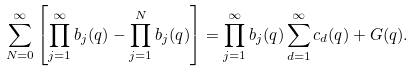Convert formula to latex. <formula><loc_0><loc_0><loc_500><loc_500>\sum _ { N = 0 } ^ { \infty } \left [ \prod _ { j = 1 } ^ { \infty } b _ { j } ( q ) - \prod _ { j = 1 } ^ { N } b _ { j } ( q ) \right ] = \prod _ { j = 1 } ^ { \infty } b _ { j } ( q ) \sum _ { d = 1 } ^ { \infty } c _ { d } ( q ) + G ( q ) .</formula> 